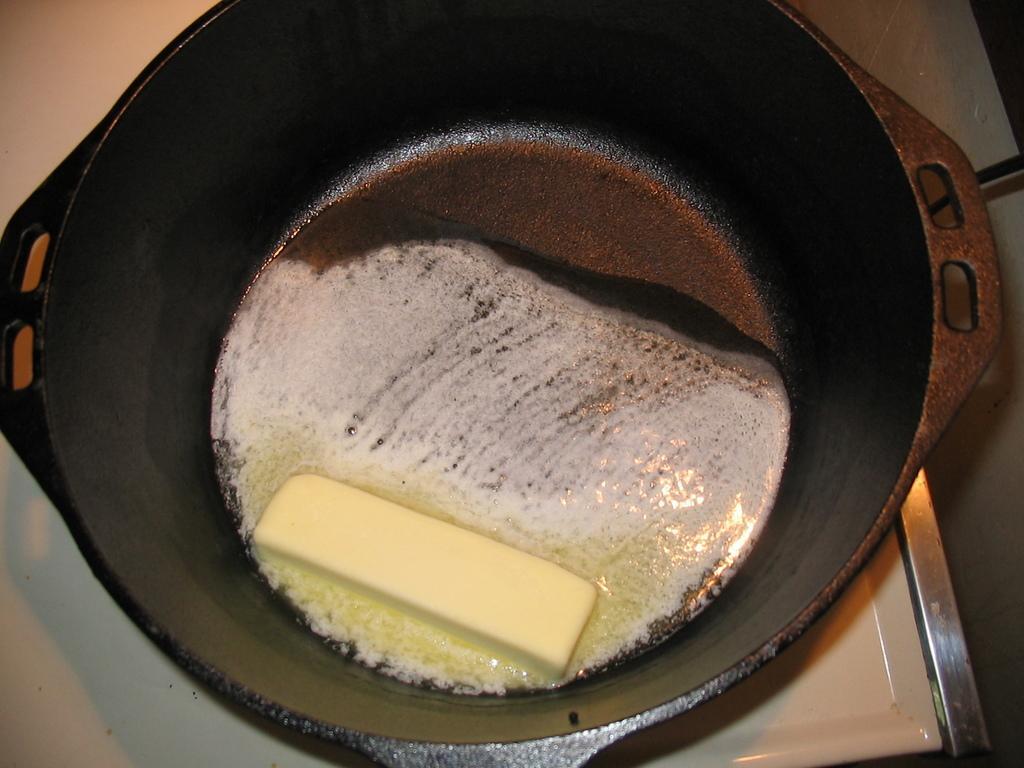Describe this image in one or two sentences. In this image I can see butter in the bowl and the bowl is in black color. 